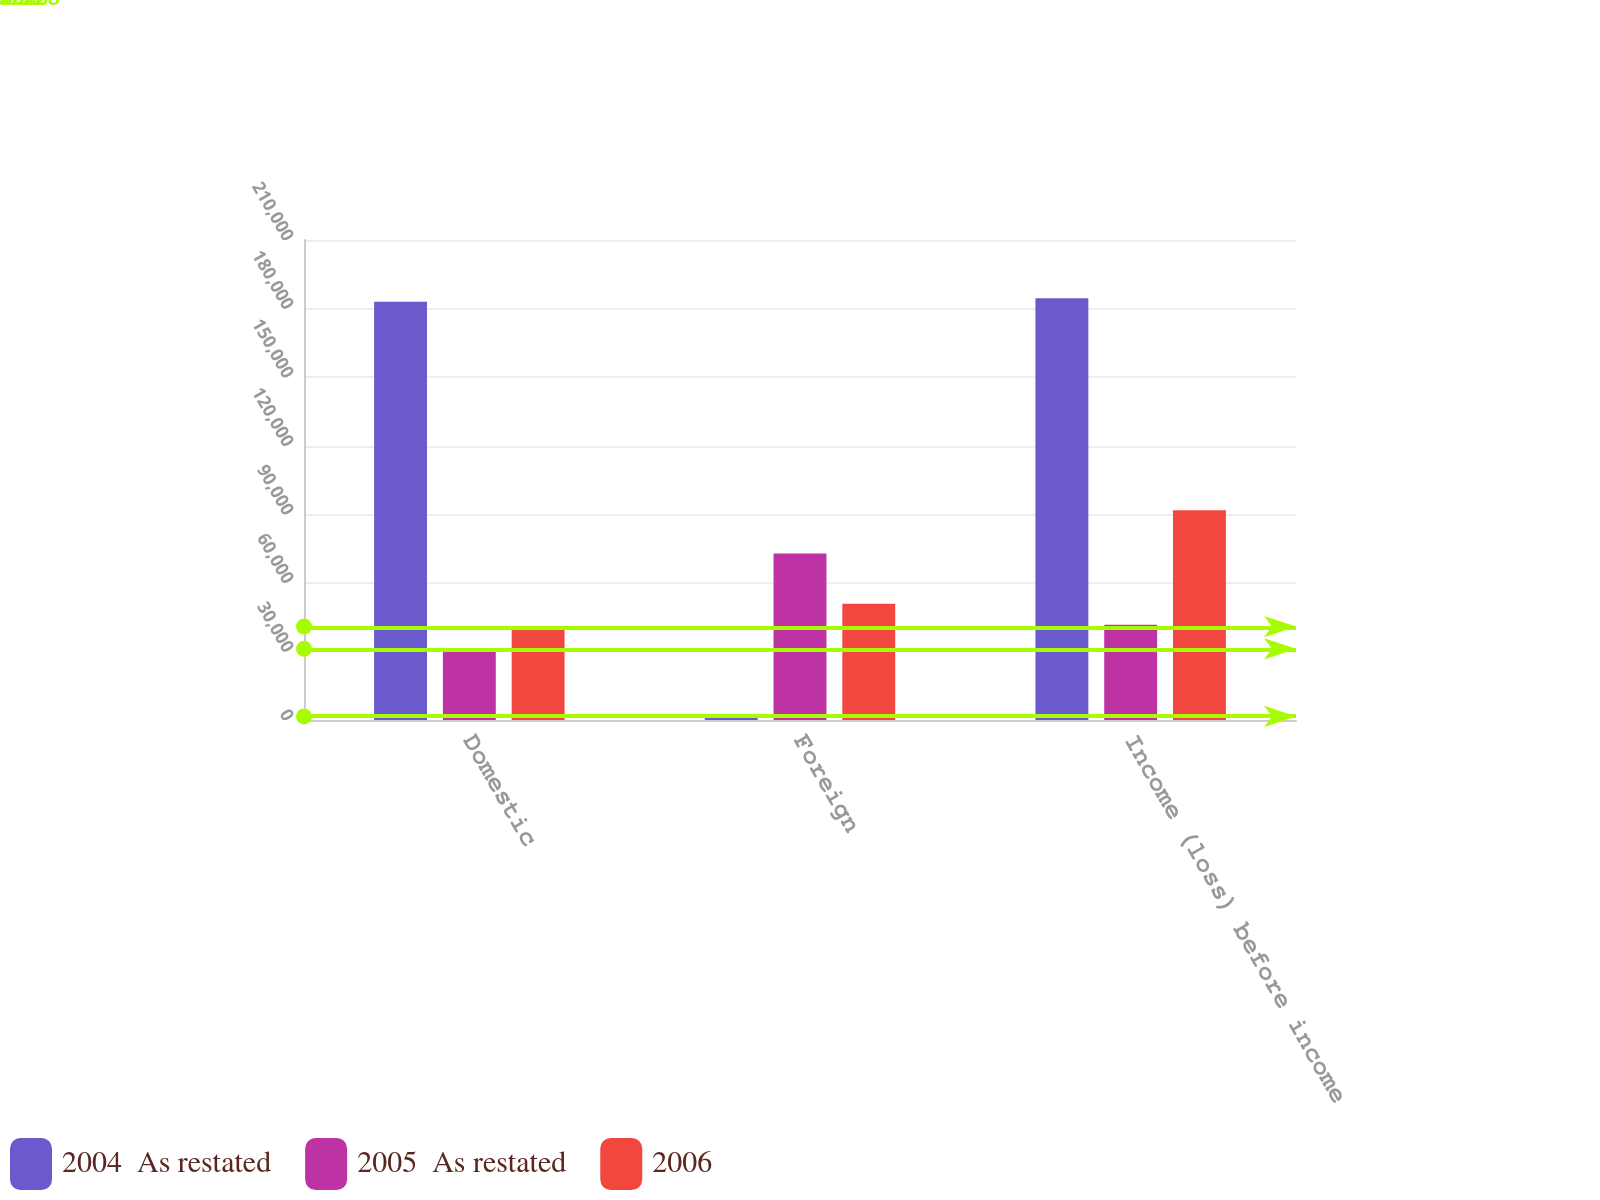Convert chart to OTSL. <chart><loc_0><loc_0><loc_500><loc_500><stacked_bar_chart><ecel><fcel>Domestic<fcel>Foreign<fcel>Income (loss) before income<nl><fcel>2004  As restated<fcel>182932<fcel>1550<fcel>184482<nl><fcel>2005  As restated<fcel>31122<fcel>72842<fcel>41720<nl><fcel>2006<fcel>40868<fcel>50876<fcel>91744<nl></chart> 